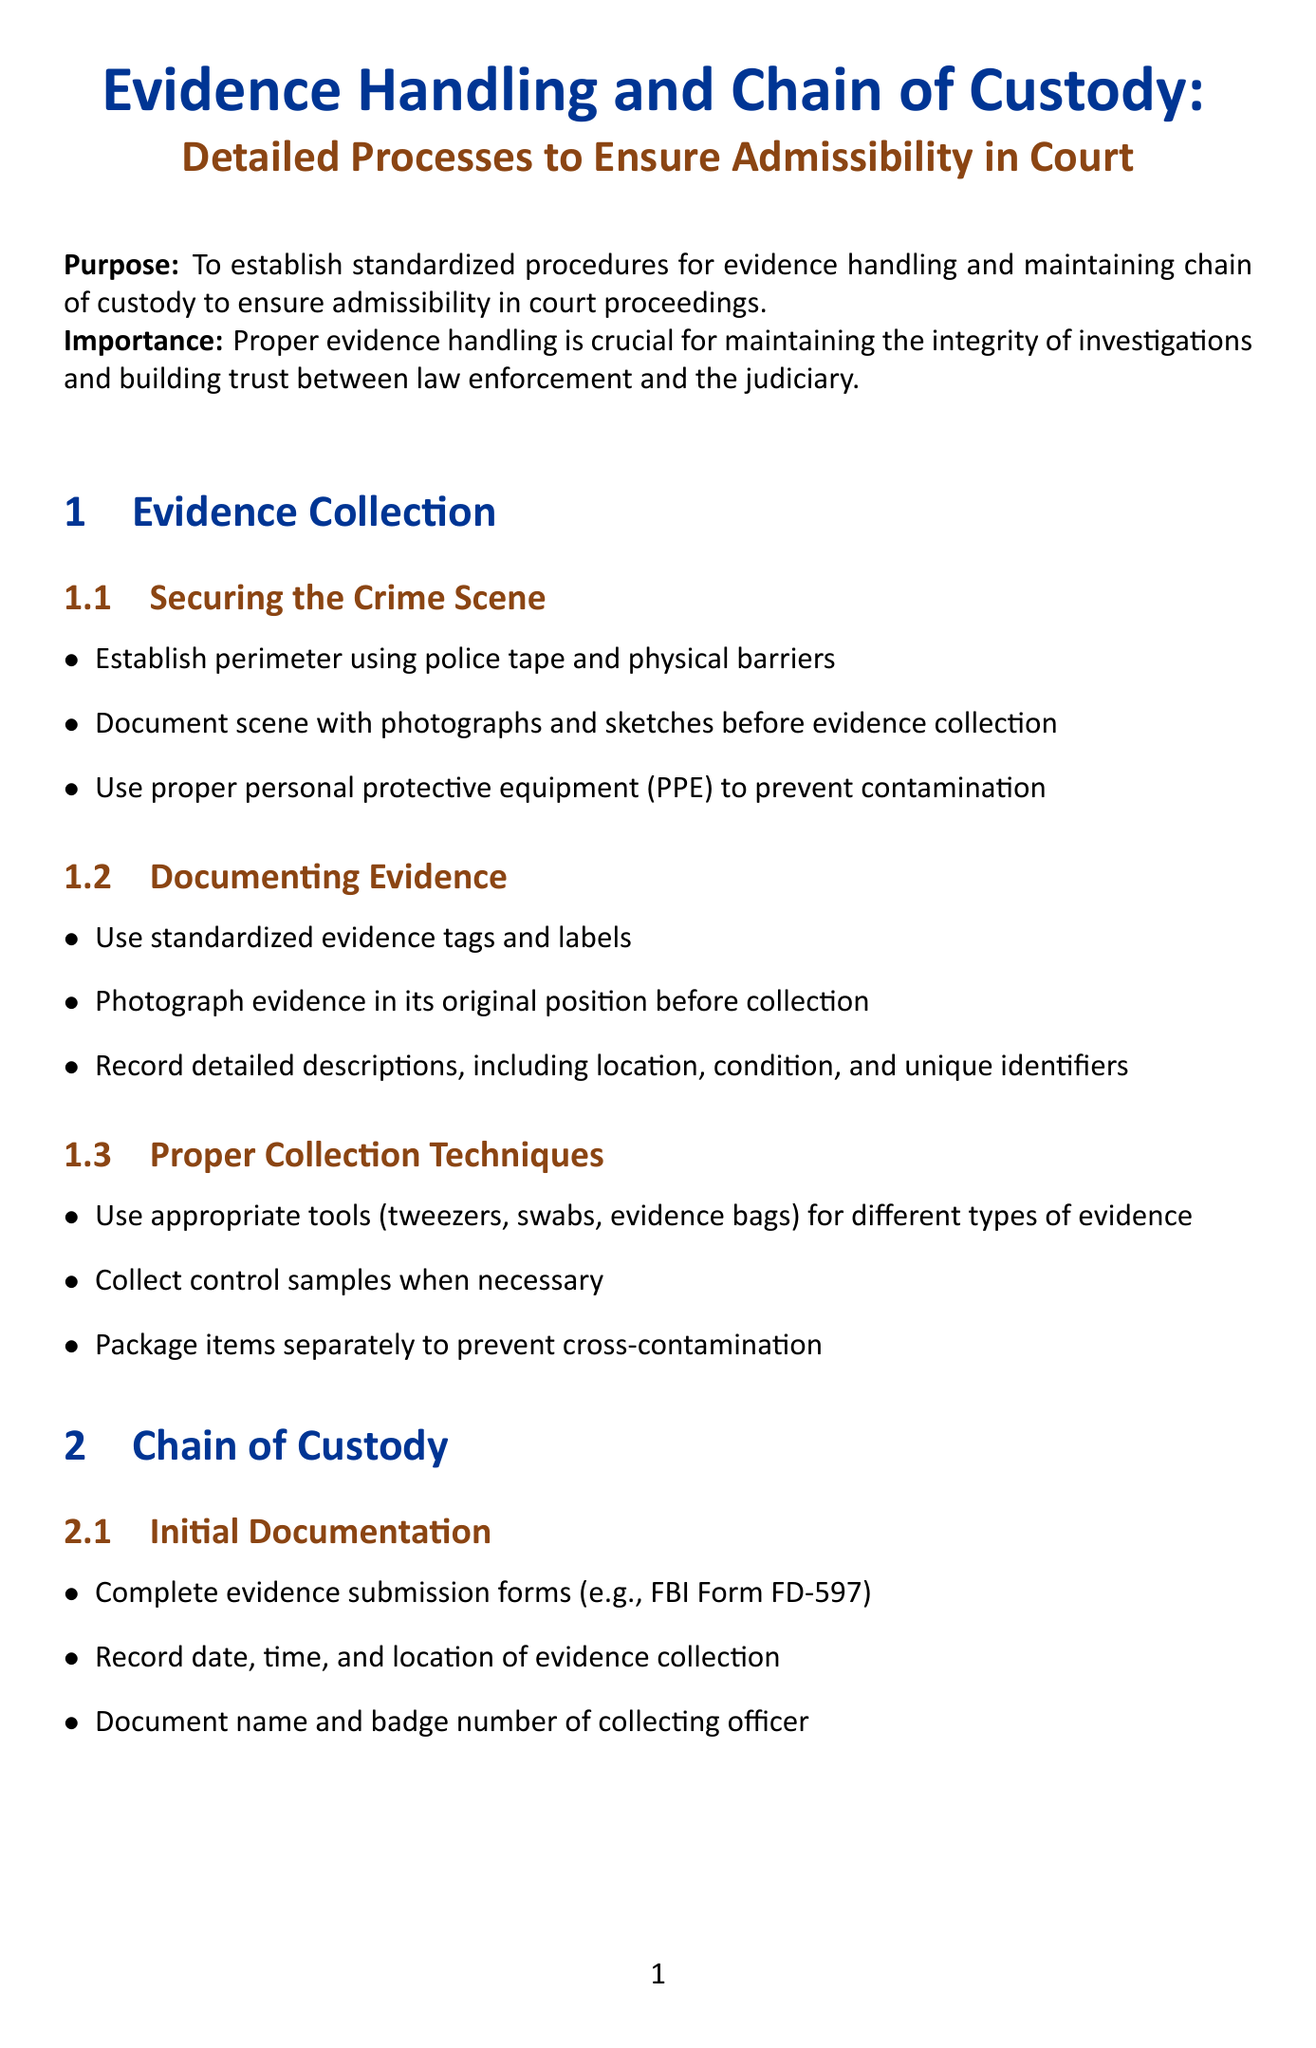what is the purpose of this manual? The purpose is to establish standardized procedures for evidence handling and maintaining chain of custody to ensure admissibility in court proceedings.
Answer: To establish standardized procedures for evidence handling and maintaining chain of custody to ensure admissibility in court proceedings what should be used to secure a crime scene? The manual specifies that police tape and physical barriers should be used to establish a perimeter for securing a crime scene.
Answer: Police tape and physical barriers which form is mentioned for initial documentation? The document mentions the FBI Form FD-597 as an evidence submission form for initial documentation.
Answer: FBI Form FD-597 what is a requirement for evidence transfer procedures? The manual states that tamper-evident seals should be used on all evidence containers during transfer procedures.
Answer: Tamper-evident seals how are digital devices to be collected? According to the manual, faraday bags should be used to prevent remote wiping or data alteration when collecting digital devices.
Answer: Faraday bags what type of software should be used for data extraction and analysis? The document specifies that certified forensic software, such as Cellebrite UFED or EnCase, should be used for data extraction and analysis.
Answer: Certified forensic software what should be conducted prior to court preparation? The manual advises conducting a thorough review of all chain of custody documents before court preparation.
Answer: Thorough review of all chain of custody documents what is emphasized regarding forensic labs? The manual emphasizes that labs should be accredited by ANAB or A2LA to ensure quality assurance.
Answer: Accredited by ANAB or A2LA 